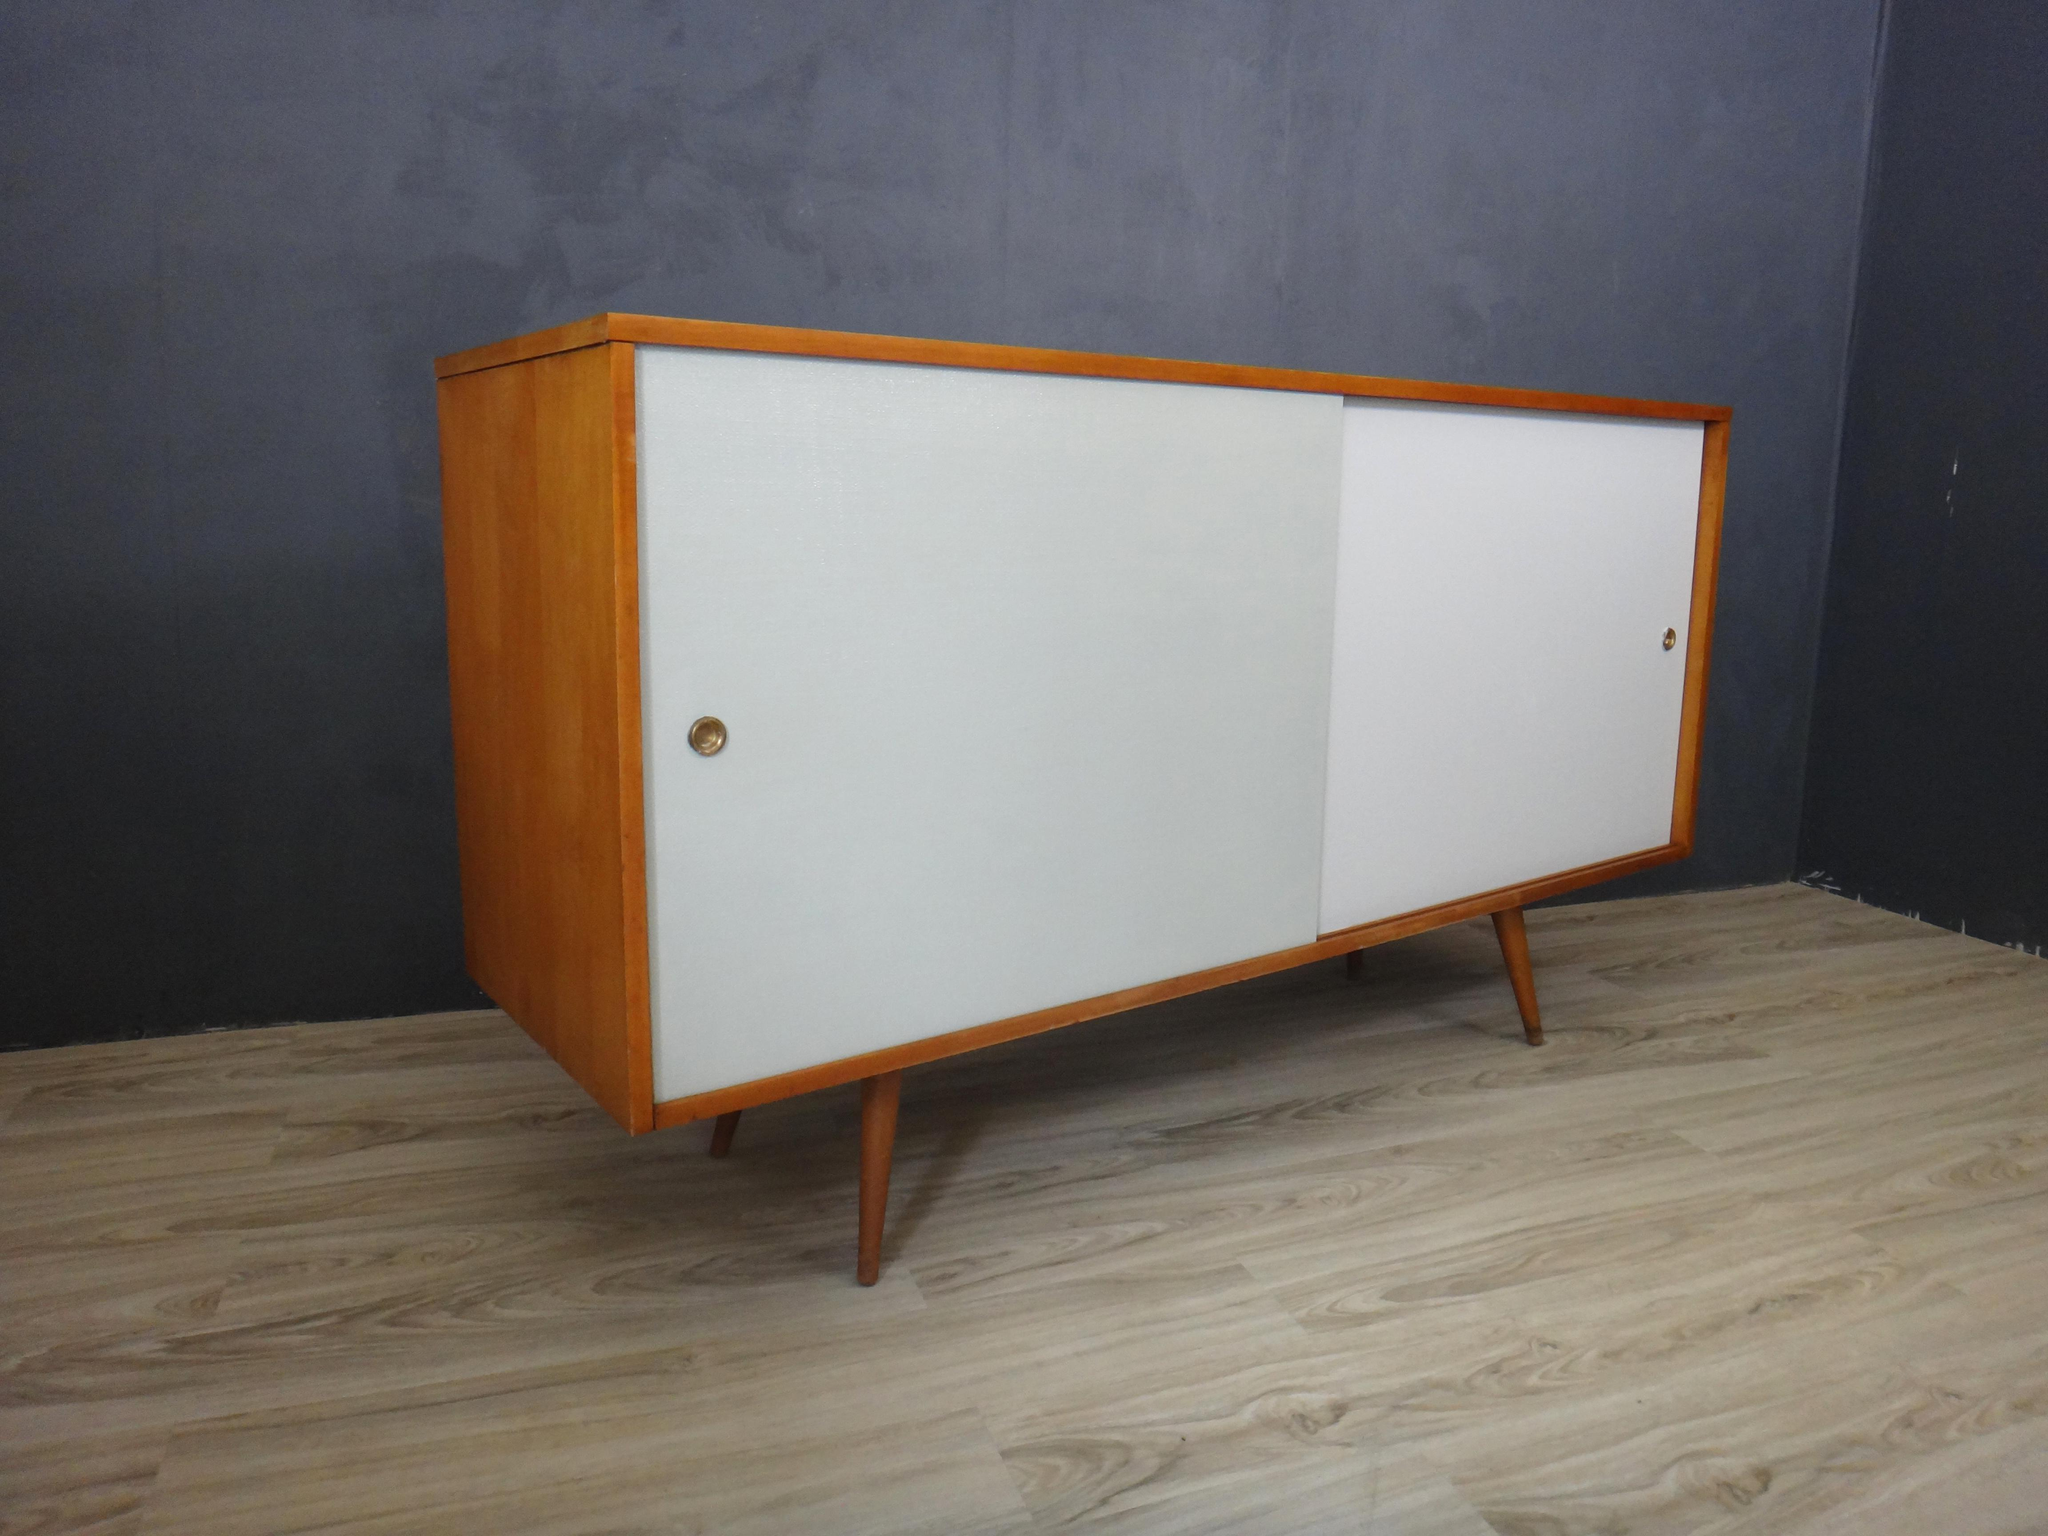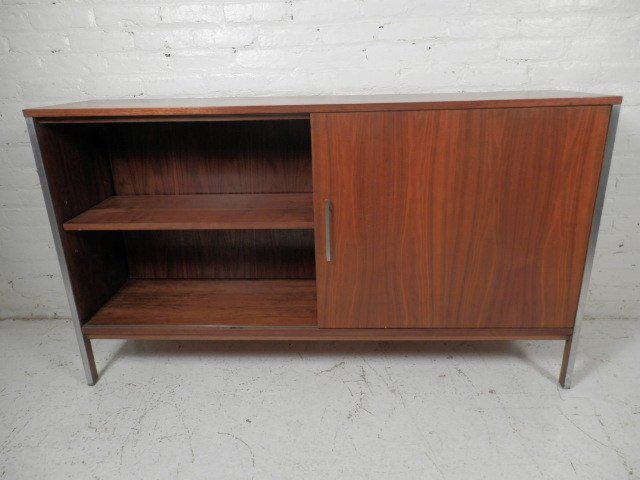The first image is the image on the left, the second image is the image on the right. For the images shown, is this caption "In 1 of the images, 1 cabinet on a solid floor has a door opened in the front." true? Answer yes or no. Yes. The first image is the image on the left, the second image is the image on the right. For the images displayed, is the sentence "Two low, wide wooden shelving units are different colors and different designs." factually correct? Answer yes or no. Yes. 